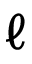<formula> <loc_0><loc_0><loc_500><loc_500>\ell</formula> 